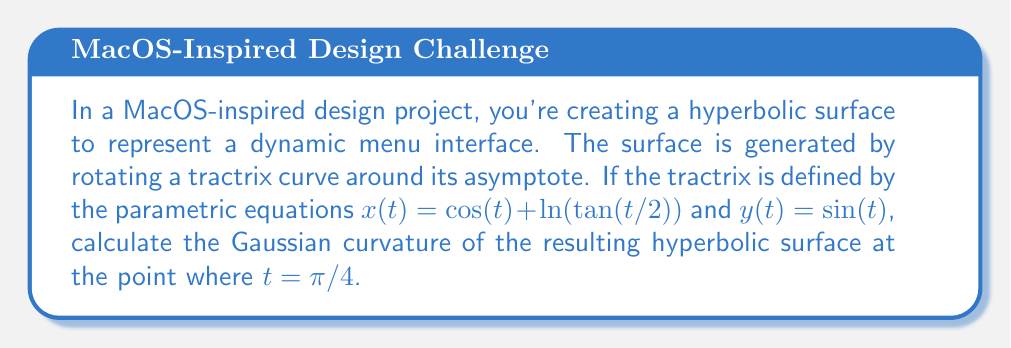Give your solution to this math problem. To calculate the Gaussian curvature of the hyperbolic surface, we'll follow these steps:

1) For a surface of revolution, the Gaussian curvature K is given by:

   $$K = -\frac{y''(t)}{y(t)(1 + (y'(t))^2)}$$

   where $y(t)$ is the generating curve.

2) We need to find $y'(t)$ and $y''(t)$:
   
   $y(t) = \sin(t)$
   $y'(t) = \cos(t)$
   $y''(t) = -\sin(t)$

3) Substitute these into the formula for K:

   $$K = -\frac{-\sin(t)}{\sin(t)(1 + (\cos(t))^2)}$$

4) Simplify:

   $$K = \frac{1}{\sin(t)(1 + (\cos(t))^2)}$$

5) Now, evaluate at $t = \pi/4$:

   $$K = \frac{1}{\sin(\pi/4)(1 + (\cos(\pi/4))^2)}$$

6) Recall that $\sin(\pi/4) = \cos(\pi/4) = \frac{1}{\sqrt{2}}$:

   $$K = \frac{1}{\frac{1}{\sqrt{2}}(1 + (\frac{1}{\sqrt{2}})^2)}$$

7) Simplify:

   $$K = \frac{\sqrt{2}}{1 + \frac{1}{2}} = \frac{\sqrt{2}}{\frac{3}{2}} = \frac{2\sqrt{2}}{3}$$

Therefore, the Gaussian curvature of the hyperbolic surface at $t = \pi/4$ is $\frac{2\sqrt{2}}{3}$.
Answer: $\frac{2\sqrt{2}}{3}$ 